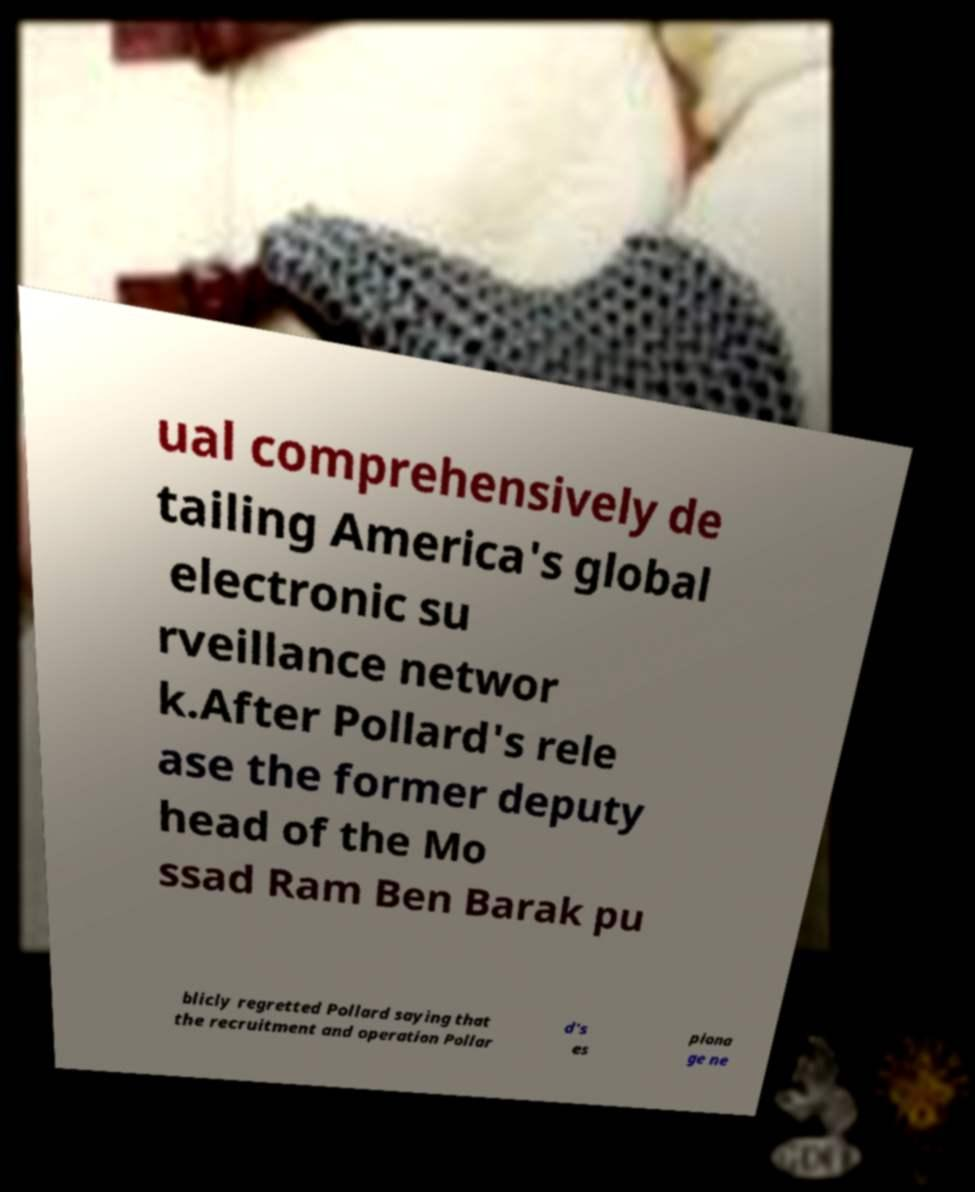Could you assist in decoding the text presented in this image and type it out clearly? ual comprehensively de tailing America's global electronic su rveillance networ k.After Pollard's rele ase the former deputy head of the Mo ssad Ram Ben Barak pu blicly regretted Pollard saying that the recruitment and operation Pollar d's es piona ge ne 